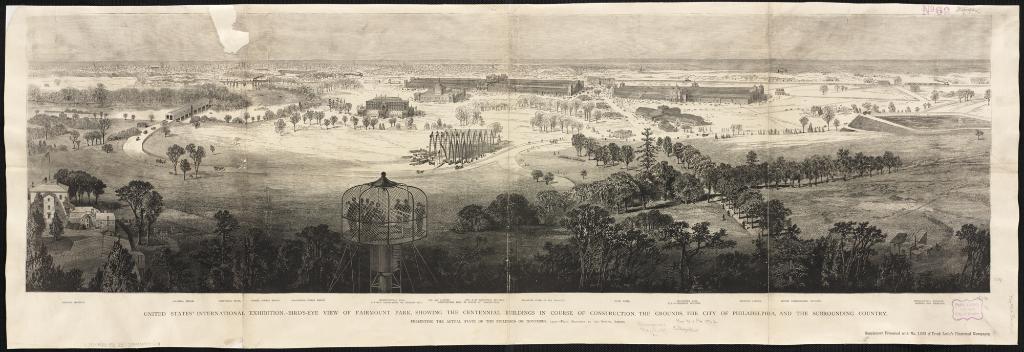In one or two sentences, can you explain what this image depicts? In this image we can see many trees and buildings. There is a cage with stand. Inside that there are few people. In the bottom of the image something is written. And this is a black and white image. 